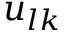Convert formula to latex. <formula><loc_0><loc_0><loc_500><loc_500>u _ { l k }</formula> 